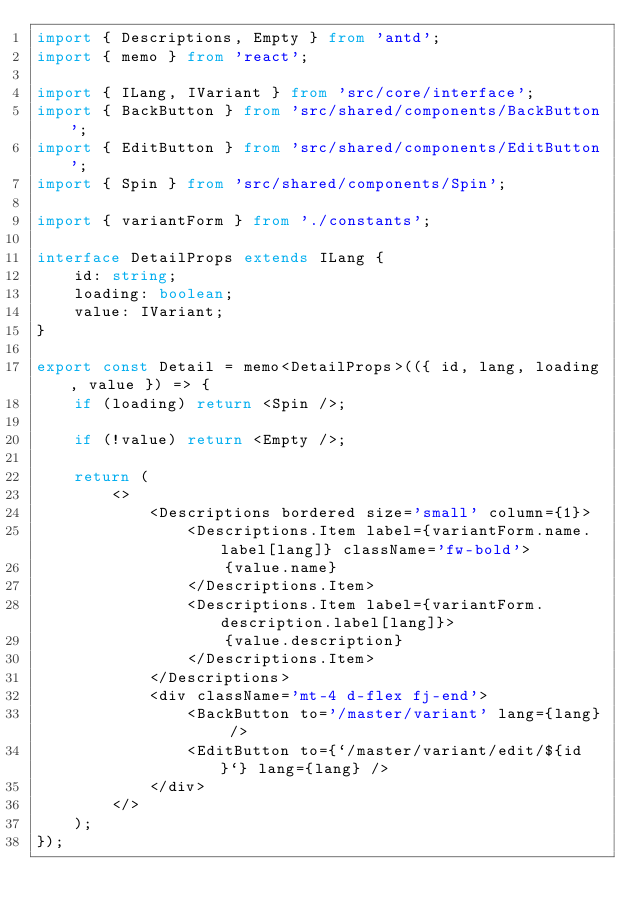Convert code to text. <code><loc_0><loc_0><loc_500><loc_500><_TypeScript_>import { Descriptions, Empty } from 'antd';
import { memo } from 'react';

import { ILang, IVariant } from 'src/core/interface';
import { BackButton } from 'src/shared/components/BackButton';
import { EditButton } from 'src/shared/components/EditButton';
import { Spin } from 'src/shared/components/Spin';

import { variantForm } from './constants';

interface DetailProps extends ILang {
    id: string;
    loading: boolean;
    value: IVariant;
}

export const Detail = memo<DetailProps>(({ id, lang, loading, value }) => {
    if (loading) return <Spin />;

    if (!value) return <Empty />;

    return (
        <>
            <Descriptions bordered size='small' column={1}>
                <Descriptions.Item label={variantForm.name.label[lang]} className='fw-bold'>
                    {value.name}
                </Descriptions.Item>
                <Descriptions.Item label={variantForm.description.label[lang]}>
                    {value.description}
                </Descriptions.Item>
            </Descriptions>
            <div className='mt-4 d-flex fj-end'>
                <BackButton to='/master/variant' lang={lang} />
                <EditButton to={`/master/variant/edit/${id}`} lang={lang} />
            </div>
        </>
    );
});
</code> 